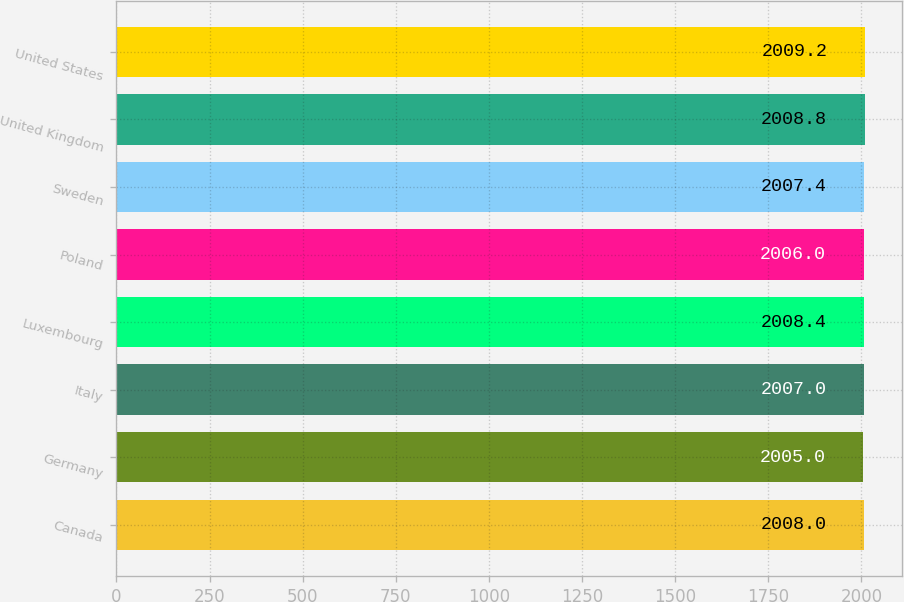Convert chart. <chart><loc_0><loc_0><loc_500><loc_500><bar_chart><fcel>Canada<fcel>Germany<fcel>Italy<fcel>Luxembourg<fcel>Poland<fcel>Sweden<fcel>United Kingdom<fcel>United States<nl><fcel>2008<fcel>2005<fcel>2007<fcel>2008.4<fcel>2006<fcel>2007.4<fcel>2008.8<fcel>2009.2<nl></chart> 